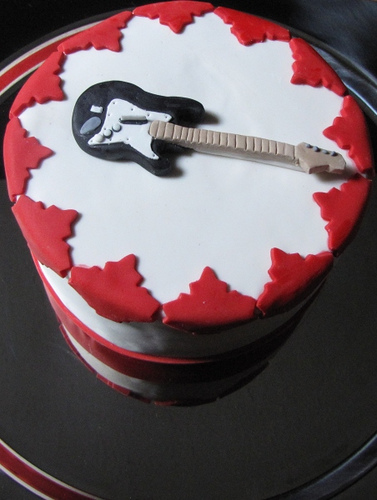<image>
Is the cake on the guitar? No. The cake is not positioned on the guitar. They may be near each other, but the cake is not supported by or resting on top of the guitar. 